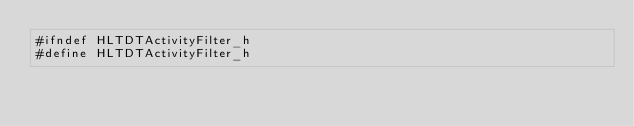Convert code to text. <code><loc_0><loc_0><loc_500><loc_500><_C_>#ifndef HLTDTActivityFilter_h
#define HLTDTActivityFilter_h</code> 